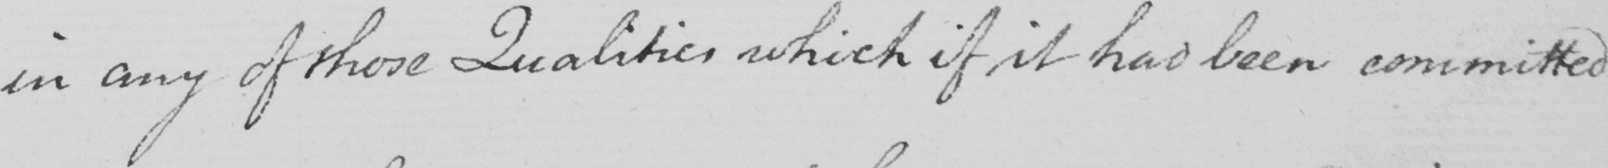Transcribe the text shown in this historical manuscript line. in any of those Qualities which if it had been committed 